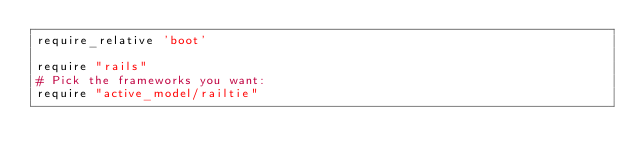<code> <loc_0><loc_0><loc_500><loc_500><_Ruby_>require_relative 'boot'

require "rails"
# Pick the frameworks you want:
require "active_model/railtie"</code> 